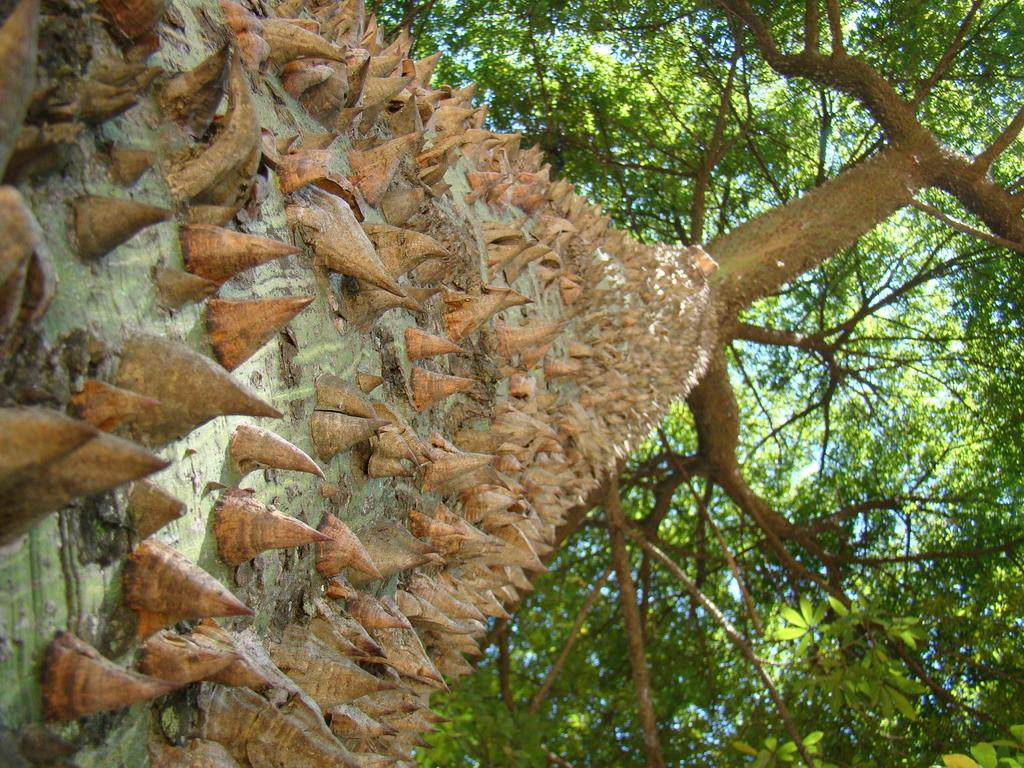What type of vegetation can be seen in the image? There are trees in the image. Can you describe any unique features of the trees? Yes, there are spikes on the tree bark. What type of cabbage is being used to balance the account in the image? There is no cabbage or account present in the image; it only features trees with spiky bark. 